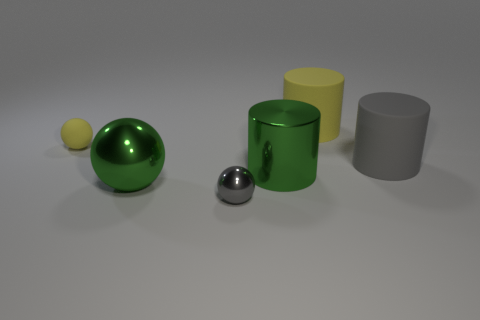Add 4 purple cubes. How many objects exist? 10 Subtract 1 yellow cylinders. How many objects are left? 5 Subtract all big yellow metal spheres. Subtract all green balls. How many objects are left? 5 Add 5 gray shiny spheres. How many gray shiny spheres are left? 6 Add 6 gray cylinders. How many gray cylinders exist? 7 